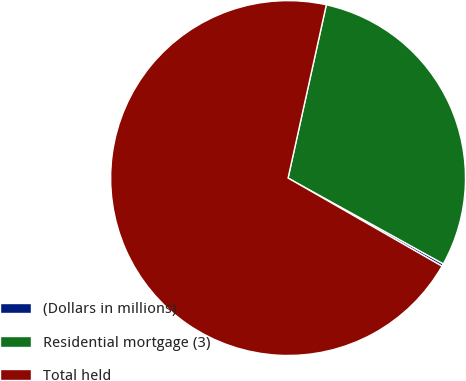Convert chart. <chart><loc_0><loc_0><loc_500><loc_500><pie_chart><fcel>(Dollars in millions)<fcel>Residential mortgage (3)<fcel>Total held<nl><fcel>0.24%<fcel>29.58%<fcel>70.19%<nl></chart> 